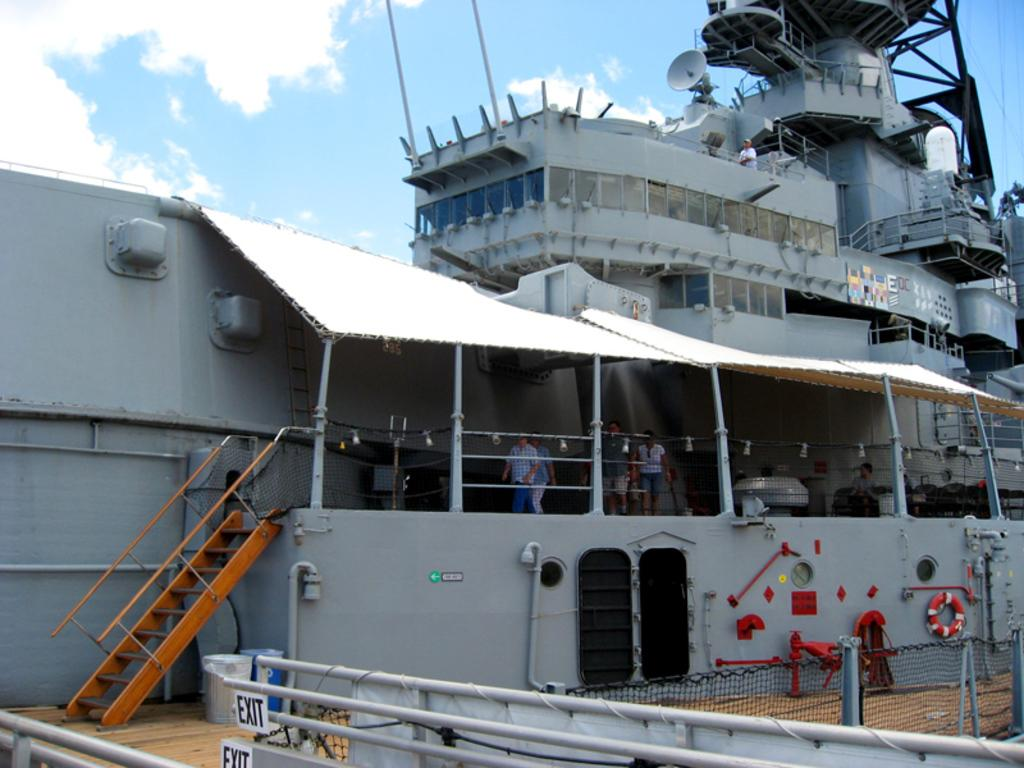Provide a one-sentence caption for the provided image. A military battle ship is being toured by civilians. 